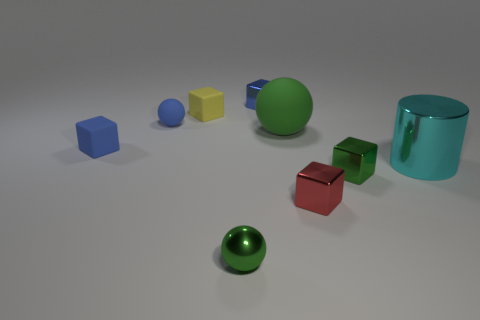Do the metallic object that is to the left of the tiny blue shiny block and the metallic thing that is behind the big rubber ball have the same size?
Your response must be concise. Yes. How many things are cyan metal things or yellow blocks?
Your answer should be very brief. 2. What is the material of the large object in front of the tiny blue rubber thing that is in front of the large green ball?
Offer a terse response. Metal. How many yellow matte objects are the same shape as the red shiny object?
Make the answer very short. 1. Is there a big cylinder that has the same color as the big matte thing?
Your response must be concise. No. How many objects are either tiny blocks in front of the cyan object or balls that are behind the red metallic thing?
Your answer should be compact. 4. There is a tiny blue shiny thing that is behind the blue ball; is there a small thing that is on the left side of it?
Provide a succinct answer. Yes. What is the shape of the green thing that is the same size as the cyan metallic cylinder?
Give a very brief answer. Sphere. How many things are either small blocks that are in front of the small rubber sphere or cyan metallic objects?
Offer a very short reply. 4. How many other things are the same material as the blue sphere?
Offer a very short reply. 3. 